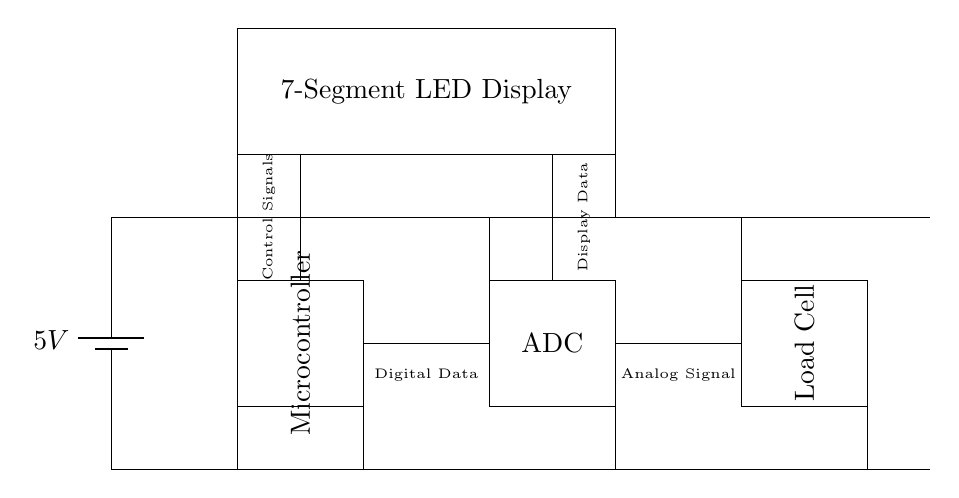What is the voltage supplied to this circuit? The voltage is supplied by a battery labeled as 5V, which indicates the potential difference used to power the components in the circuit.
Answer: 5V What component converts analog signals to digital data? The component responsible for converting analog signals to digital data is the ADC (Analog to Digital Converter), which receives the analog signal from the load cell.
Answer: ADC How many segments does the LED display have? The LED display in this circuit is described as a "7-Segment LED Display," which typically consists of seven segments that can light up to display numerals.
Answer: Seven What is the primary function of the load cell in this circuit? The load cell's primary function is to measure weight and provide an analog signal that corresponds to the amount of weight applied, which is then processed by the ADC.
Answer: Measure weight What type of signals does the microcontroller handle from the ADC? The microcontroller handles digital data from the ADC after it has converted the analog signal from the load cell into a format that the microcontroller can understand and process.
Answer: Digital Data Where does the display data come from in this circuit? The display data is generated by the microcontroller, which is responsible for processing the input from the ADC and then sending the appropriate signals to the 7-segment LED display for visual output.
Answer: Microcontroller 